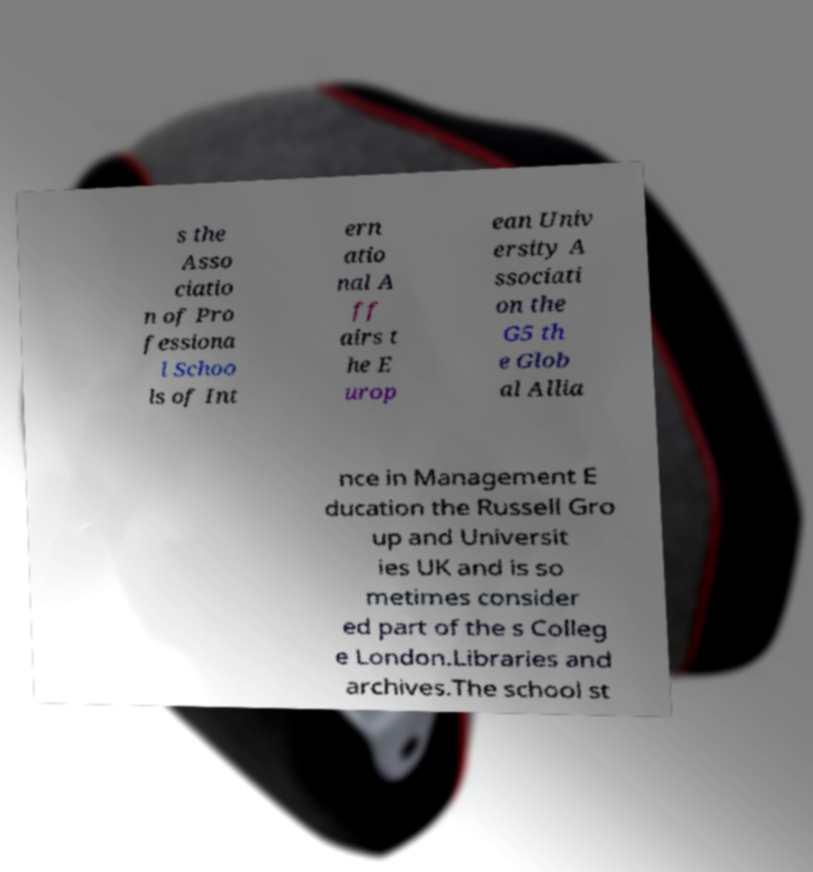Could you extract and type out the text from this image? s the Asso ciatio n of Pro fessiona l Schoo ls of Int ern atio nal A ff airs t he E urop ean Univ ersity A ssociati on the G5 th e Glob al Allia nce in Management E ducation the Russell Gro up and Universit ies UK and is so metimes consider ed part of the s Colleg e London.Libraries and archives.The school st 